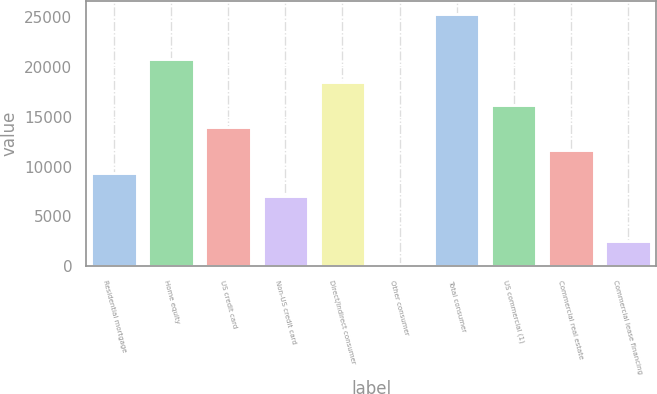Convert chart. <chart><loc_0><loc_0><loc_500><loc_500><bar_chart><fcel>Residential mortgage<fcel>Home equity<fcel>US credit card<fcel>Non-US credit card<fcel>Direct/Indirect consumer<fcel>Other consumer<fcel>Total consumer<fcel>US commercial (1)<fcel>Commercial real estate<fcel>Commercial lease financing<nl><fcel>9350.2<fcel>20784.2<fcel>13923.8<fcel>7063.4<fcel>18497.4<fcel>203<fcel>25357.8<fcel>16210.6<fcel>11637<fcel>2489.8<nl></chart> 